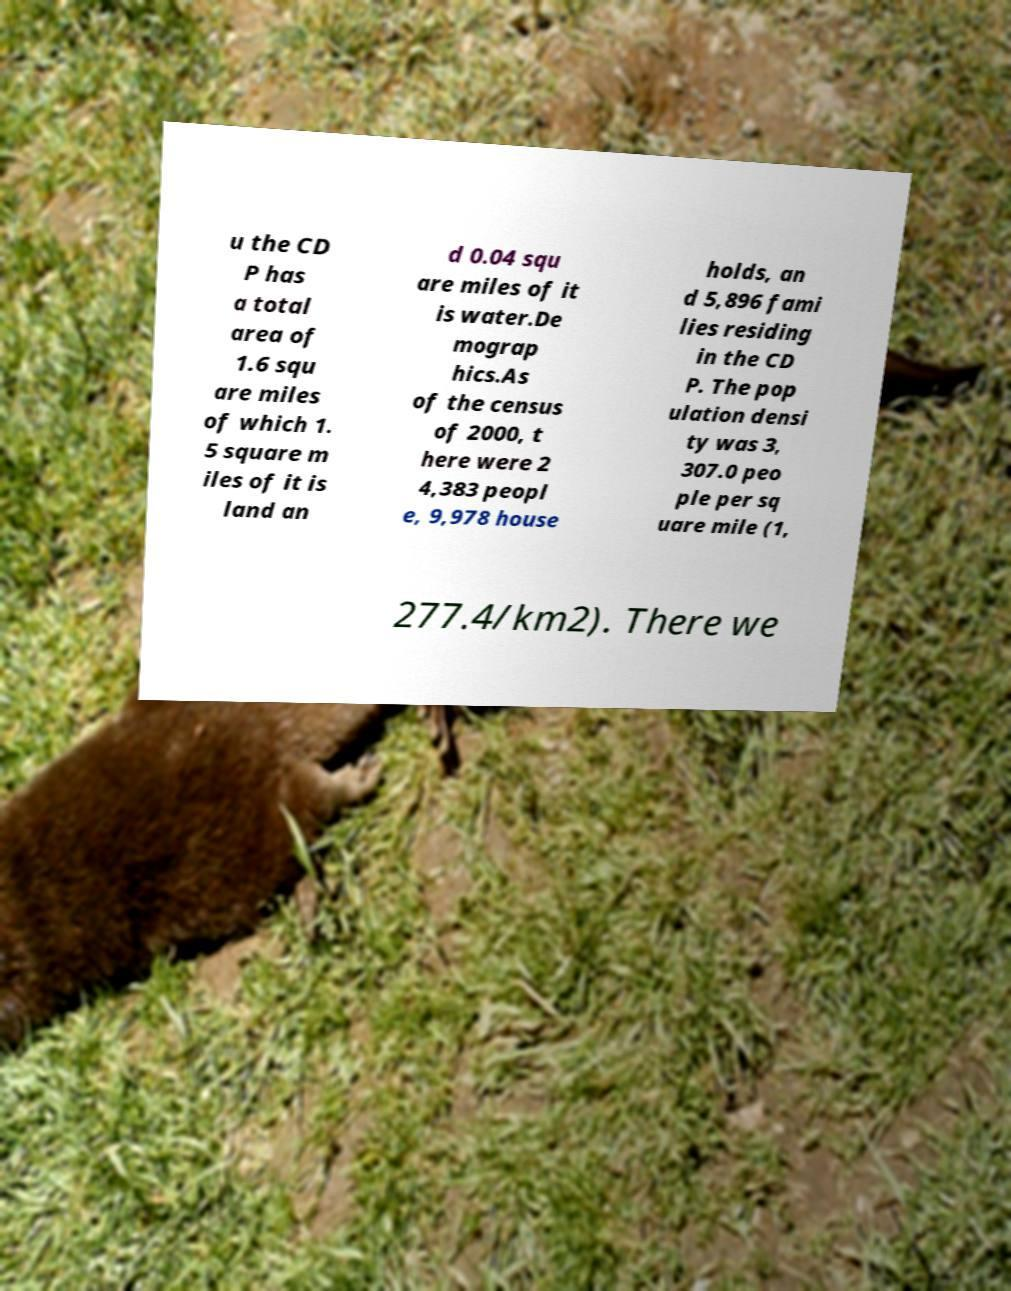Can you accurately transcribe the text from the provided image for me? u the CD P has a total area of 1.6 squ are miles of which 1. 5 square m iles of it is land an d 0.04 squ are miles of it is water.De mograp hics.As of the census of 2000, t here were 2 4,383 peopl e, 9,978 house holds, an d 5,896 fami lies residing in the CD P. The pop ulation densi ty was 3, 307.0 peo ple per sq uare mile (1, 277.4/km2). There we 